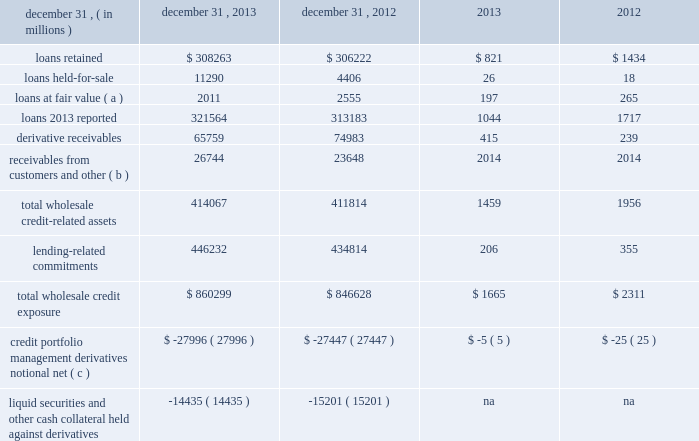Management 2019s discussion and analysis 130 jpmorgan chase & co./2013 annual report wholesale credit portfolio the wholesale credit environment remained favorable throughout 2013 driving an increase in commercial client activity .
Discipline in underwriting across all areas of lending continues to remain a key point of focus , consistent with evolving market conditions and the firm 2019s risk management activities .
The wholesale portfolio is actively managed , in part by conducting ongoing , in-depth reviews of credit quality and of industry , product and client concentrations .
During the year , wholesale criticized assets and nonperforming assets decreased from higher levels experienced in 2012 , including a reduction in nonaccrual loans by 39% ( 39 % ) .
As of december 31 , 2013 , wholesale exposure ( primarily cib , cb and am ) increased by $ 13.7 billion from december 31 , 2012 , primarily driven by increases of $ 11.4 billion in lending-related commitments and $ 8.4 billion in loans reflecting increased client activity primarily in cb and am .
These increases were partially offset by a $ 9.2 billion decrease in derivative receivables .
Derivative receivables decreased predominantly due to reductions in interest rate derivatives driven by an increase in interest rates and reductions in commodity derivatives due to market movements .
The decreases were partially offset by an increase in equity derivatives driven by a rise in equity markets .
Wholesale credit portfolio december 31 , credit exposure nonperforming ( d ) .
Receivables from customers and other ( b ) 26744 23648 2014 2014 total wholesale credit- related assets 414067 411814 1459 1956 lending-related commitments 446232 434814 206 355 total wholesale credit exposure $ 860299 $ 846628 $ 1665 $ 2311 credit portfolio management derivatives notional , net ( c ) $ ( 27996 ) $ ( 27447 ) $ ( 5 ) $ ( 25 ) liquid securities and other cash collateral held against derivatives ( 14435 ) ( 15201 ) na na ( a ) during 2013 , certain loans that resulted from restructurings that were previously classified as performing were reclassified as nonperforming loans .
Prior periods were revised to conform with the current presentation .
( b ) receivables from customers and other primarily includes margin loans to prime and retail brokerage customers ; these are classified in accrued interest and accounts receivable on the consolidated balance sheets .
( c ) represents the net notional amount of protection purchased and sold through credit derivatives used to manage both performing and nonperforming wholesale credit exposures ; these derivatives do not qualify for hedge accounting under u.s .
Gaap .
Excludes the synthetic credit portfolio .
For additional information , see credit derivatives on pages 137 2013138 , and note 6 on pages 220 2013233 of this annual report .
( d ) excludes assets acquired in loan satisfactions. .
What was the percentage change in loans reported from 2012 to 2013? 
Computations: ((321564 - 313183) / 313183)
Answer: 0.02676. Management 2019s discussion and analysis 130 jpmorgan chase & co./2013 annual report wholesale credit portfolio the wholesale credit environment remained favorable throughout 2013 driving an increase in commercial client activity .
Discipline in underwriting across all areas of lending continues to remain a key point of focus , consistent with evolving market conditions and the firm 2019s risk management activities .
The wholesale portfolio is actively managed , in part by conducting ongoing , in-depth reviews of credit quality and of industry , product and client concentrations .
During the year , wholesale criticized assets and nonperforming assets decreased from higher levels experienced in 2012 , including a reduction in nonaccrual loans by 39% ( 39 % ) .
As of december 31 , 2013 , wholesale exposure ( primarily cib , cb and am ) increased by $ 13.7 billion from december 31 , 2012 , primarily driven by increases of $ 11.4 billion in lending-related commitments and $ 8.4 billion in loans reflecting increased client activity primarily in cb and am .
These increases were partially offset by a $ 9.2 billion decrease in derivative receivables .
Derivative receivables decreased predominantly due to reductions in interest rate derivatives driven by an increase in interest rates and reductions in commodity derivatives due to market movements .
The decreases were partially offset by an increase in equity derivatives driven by a rise in equity markets .
Wholesale credit portfolio december 31 , credit exposure nonperforming ( d ) .
Receivables from customers and other ( b ) 26744 23648 2014 2014 total wholesale credit- related assets 414067 411814 1459 1956 lending-related commitments 446232 434814 206 355 total wholesale credit exposure $ 860299 $ 846628 $ 1665 $ 2311 credit portfolio management derivatives notional , net ( c ) $ ( 27996 ) $ ( 27447 ) $ ( 5 ) $ ( 25 ) liquid securities and other cash collateral held against derivatives ( 14435 ) ( 15201 ) na na ( a ) during 2013 , certain loans that resulted from restructurings that were previously classified as performing were reclassified as nonperforming loans .
Prior periods were revised to conform with the current presentation .
( b ) receivables from customers and other primarily includes margin loans to prime and retail brokerage customers ; these are classified in accrued interest and accounts receivable on the consolidated balance sheets .
( c ) represents the net notional amount of protection purchased and sold through credit derivatives used to manage both performing and nonperforming wholesale credit exposures ; these derivatives do not qualify for hedge accounting under u.s .
Gaap .
Excludes the synthetic credit portfolio .
For additional information , see credit derivatives on pages 137 2013138 , and note 6 on pages 220 2013233 of this annual report .
( d ) excludes assets acquired in loan satisfactions. .
What was the percentage change in total wholesale credit-related assets from 2012 to 2013? 
Computations: ((414067 - 411814) / 411814)
Answer: 0.00547. 